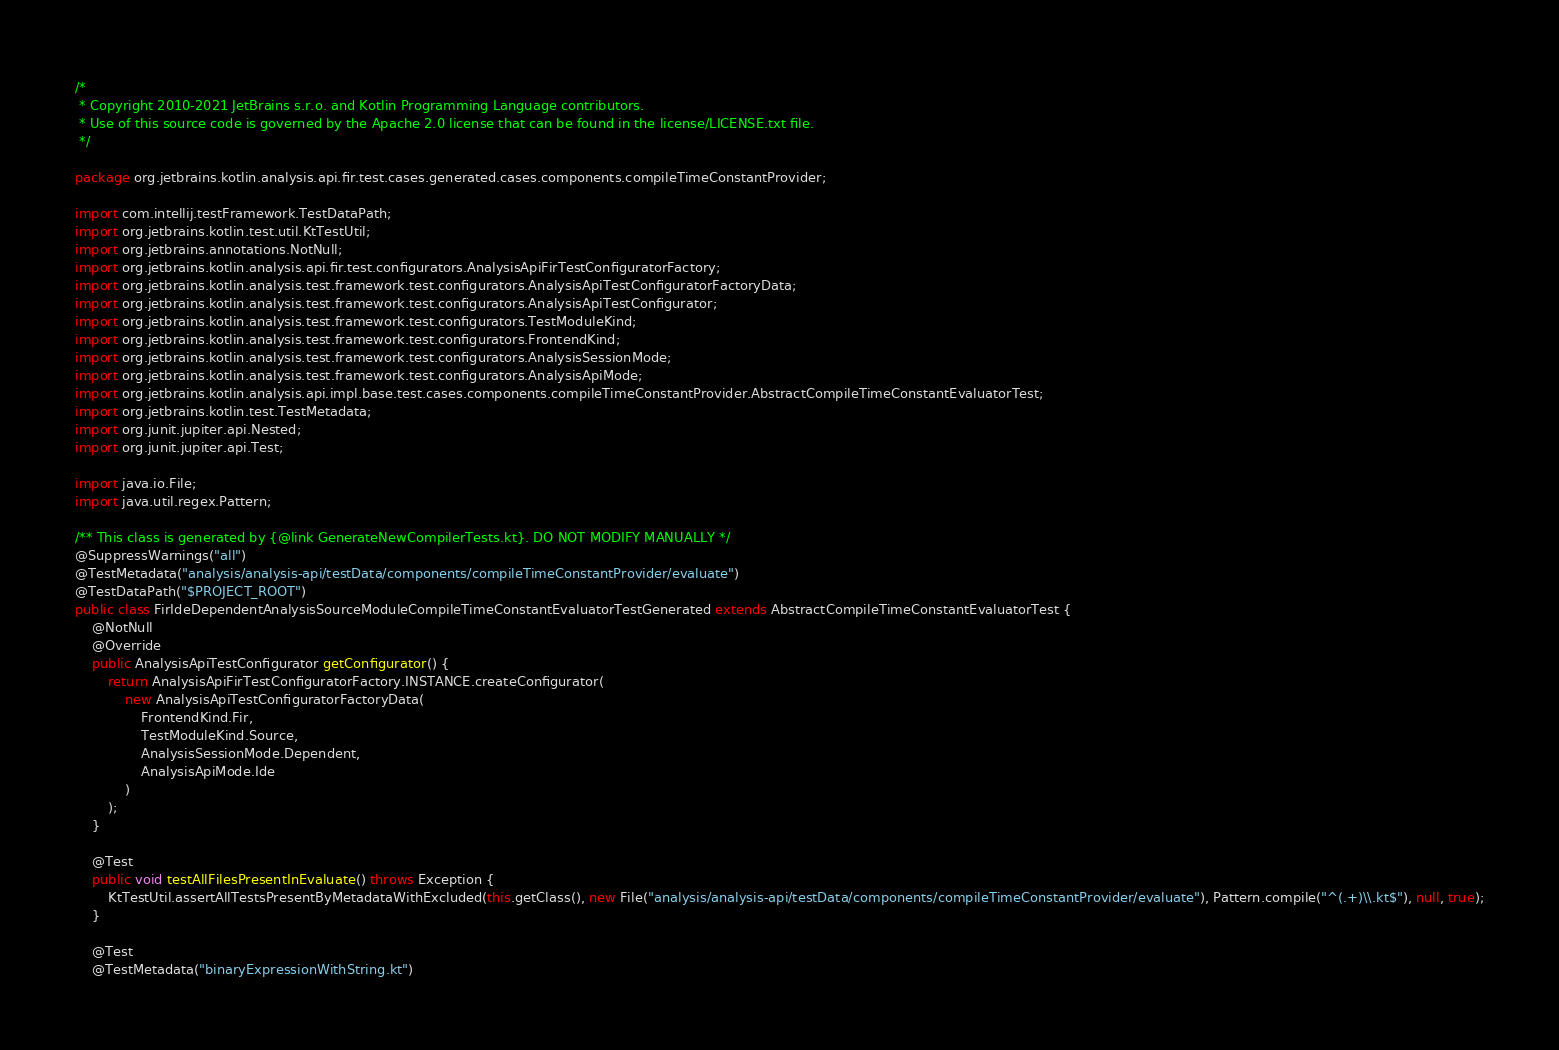<code> <loc_0><loc_0><loc_500><loc_500><_Java_>/*
 * Copyright 2010-2021 JetBrains s.r.o. and Kotlin Programming Language contributors.
 * Use of this source code is governed by the Apache 2.0 license that can be found in the license/LICENSE.txt file.
 */

package org.jetbrains.kotlin.analysis.api.fir.test.cases.generated.cases.components.compileTimeConstantProvider;

import com.intellij.testFramework.TestDataPath;
import org.jetbrains.kotlin.test.util.KtTestUtil;
import org.jetbrains.annotations.NotNull;
import org.jetbrains.kotlin.analysis.api.fir.test.configurators.AnalysisApiFirTestConfiguratorFactory;
import org.jetbrains.kotlin.analysis.test.framework.test.configurators.AnalysisApiTestConfiguratorFactoryData;
import org.jetbrains.kotlin.analysis.test.framework.test.configurators.AnalysisApiTestConfigurator;
import org.jetbrains.kotlin.analysis.test.framework.test.configurators.TestModuleKind;
import org.jetbrains.kotlin.analysis.test.framework.test.configurators.FrontendKind;
import org.jetbrains.kotlin.analysis.test.framework.test.configurators.AnalysisSessionMode;
import org.jetbrains.kotlin.analysis.test.framework.test.configurators.AnalysisApiMode;
import org.jetbrains.kotlin.analysis.api.impl.base.test.cases.components.compileTimeConstantProvider.AbstractCompileTimeConstantEvaluatorTest;
import org.jetbrains.kotlin.test.TestMetadata;
import org.junit.jupiter.api.Nested;
import org.junit.jupiter.api.Test;

import java.io.File;
import java.util.regex.Pattern;

/** This class is generated by {@link GenerateNewCompilerTests.kt}. DO NOT MODIFY MANUALLY */
@SuppressWarnings("all")
@TestMetadata("analysis/analysis-api/testData/components/compileTimeConstantProvider/evaluate")
@TestDataPath("$PROJECT_ROOT")
public class FirIdeDependentAnalysisSourceModuleCompileTimeConstantEvaluatorTestGenerated extends AbstractCompileTimeConstantEvaluatorTest {
    @NotNull
    @Override
    public AnalysisApiTestConfigurator getConfigurator() {
        return AnalysisApiFirTestConfiguratorFactory.INSTANCE.createConfigurator(
            new AnalysisApiTestConfiguratorFactoryData(
                FrontendKind.Fir,
                TestModuleKind.Source,
                AnalysisSessionMode.Dependent,
                AnalysisApiMode.Ide
            )
        );
    }

    @Test
    public void testAllFilesPresentInEvaluate() throws Exception {
        KtTestUtil.assertAllTestsPresentByMetadataWithExcluded(this.getClass(), new File("analysis/analysis-api/testData/components/compileTimeConstantProvider/evaluate"), Pattern.compile("^(.+)\\.kt$"), null, true);
    }

    @Test
    @TestMetadata("binaryExpressionWithString.kt")</code> 